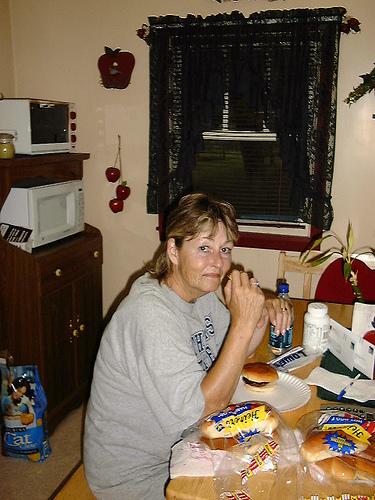Does this person own a cat?
Short answer required. Yes. What color is the curtain?
Keep it brief. Black. What kind of buns are on the table?
Concise answer only. Hamburger. What is she sitting on?
Quick response, please. Bench. Is she stylish?
Short answer required. No. How many remotes are on the table?
Write a very short answer. 0. Is she wearing a ring?
Short answer required. Yes. 